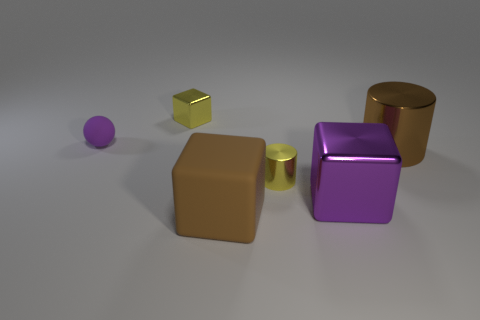There is a large thing that is the same color as the large metal cylinder; what is its material?
Make the answer very short. Rubber. How many metal objects are big things or large yellow blocks?
Offer a terse response. 2. The small purple thing is what shape?
Ensure brevity in your answer.  Sphere. How many yellow blocks have the same material as the tiny purple thing?
Offer a very short reply. 0. There is a ball that is the same material as the big brown block; what is its color?
Your response must be concise. Purple. There is a matte thing that is behind the yellow cylinder; is it the same size as the brown cylinder?
Give a very brief answer. No. What is the color of the other object that is the same shape as the brown metallic thing?
Your response must be concise. Yellow. There is a metal thing that is on the left side of the brown thing that is in front of the large metal object behind the yellow shiny cylinder; what is its shape?
Your response must be concise. Cube. Do the brown metallic object and the purple metallic thing have the same shape?
Make the answer very short. No. What shape is the large metallic object that is behind the large cube on the right side of the small yellow cylinder?
Your answer should be compact. Cylinder. 